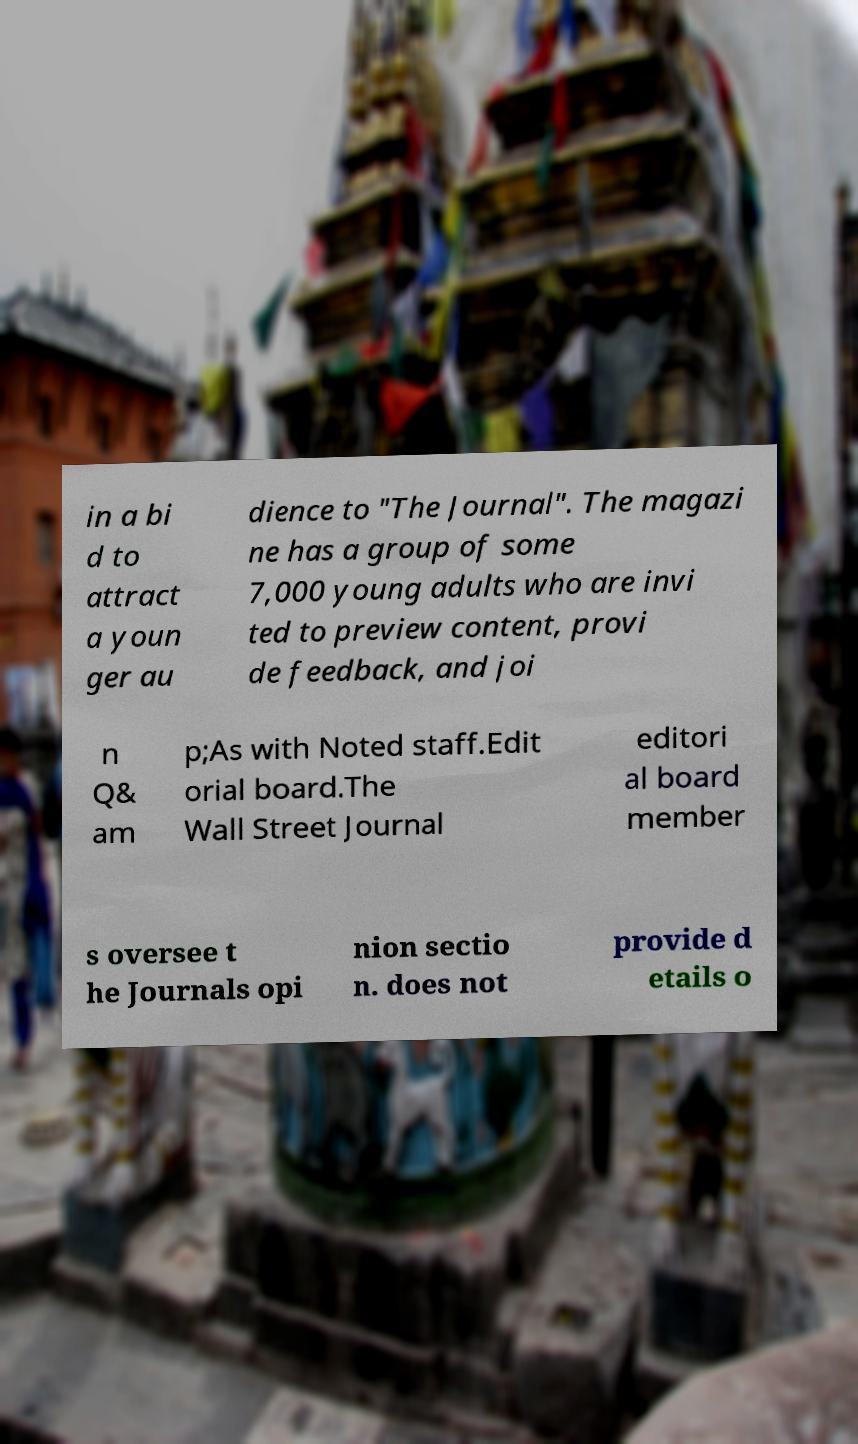Can you read and provide the text displayed in the image?This photo seems to have some interesting text. Can you extract and type it out for me? in a bi d to attract a youn ger au dience to "The Journal". The magazi ne has a group of some 7,000 young adults who are invi ted to preview content, provi de feedback, and joi n Q& am p;As with Noted staff.Edit orial board.The Wall Street Journal editori al board member s oversee t he Journals opi nion sectio n. does not provide d etails o 